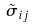<formula> <loc_0><loc_0><loc_500><loc_500>\tilde { \sigma } _ { i j }</formula> 